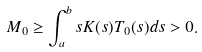<formula> <loc_0><loc_0><loc_500><loc_500>M _ { 0 } \geq \int _ { a } ^ { b } s K ( s ) T _ { 0 } ( s ) d s > 0 .</formula> 